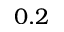<formula> <loc_0><loc_0><loc_500><loc_500>0 . 2</formula> 